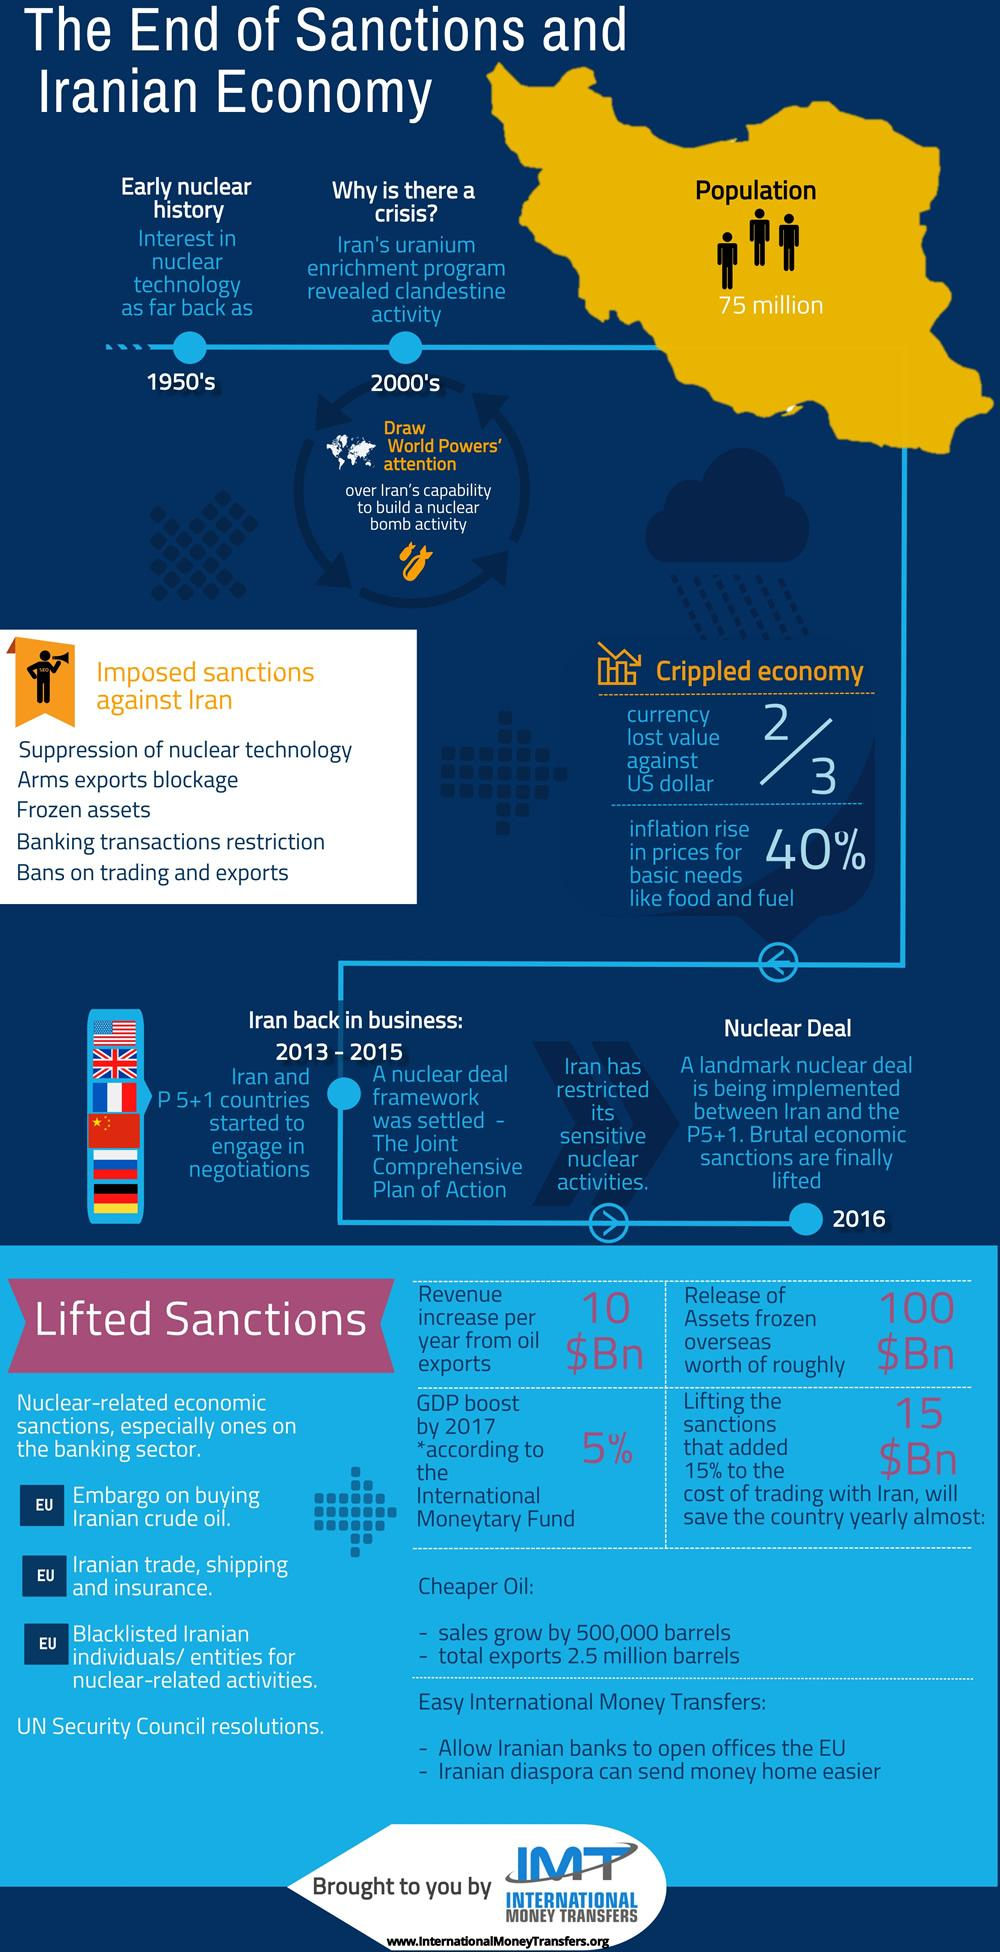Mention a couple of crucial points in this snapshot. The GDP increase in Iran by 2017 was approximately 5%. In 2013-2015, Iran restricted its sensitive nuclear activities. The nuclear deal between Iran and the P5+1 countries was implemented in 2016. 